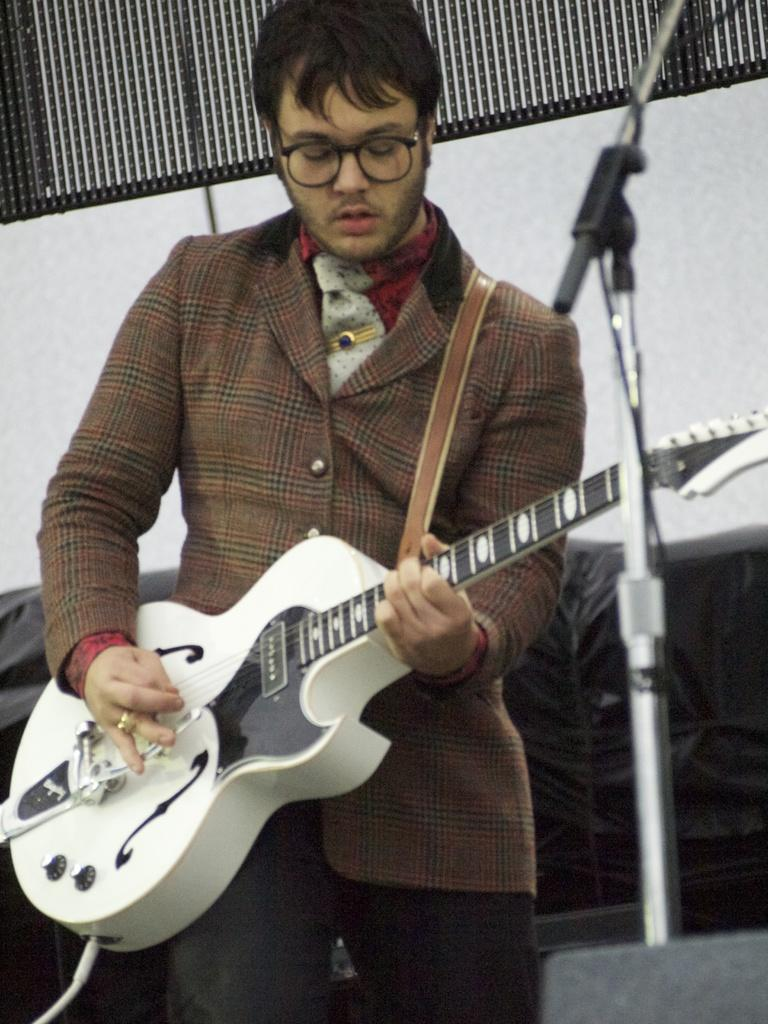What is the person in the image doing? The person is playing a white guitar. What type of clothing is the person wearing? The person is wearing a suit. What accessory is the person wearing on their face? The person is wearing glasses. What equipment is present for amplifying the person's voice? There is a microphone in the image, and a microphone stand is also visible. What color is the wall in the background of the image? The wall in the background of the image is white. What direction is the banana facing in the image? There is no banana present in the image. What type of test is being conducted in the image? There is no test being conducted in the image; it features a person playing a guitar. 